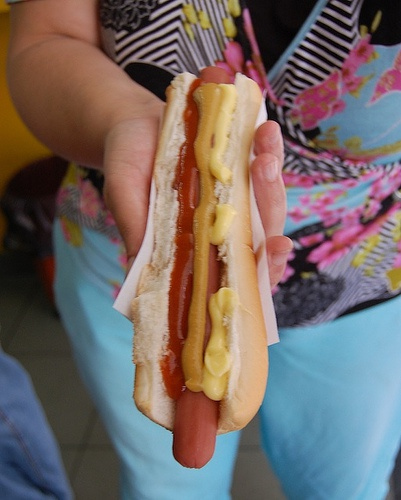Describe the objects in this image and their specific colors. I can see people in olive, brown, gray, and black tones and hot dog in olive, tan, brown, and maroon tones in this image. 